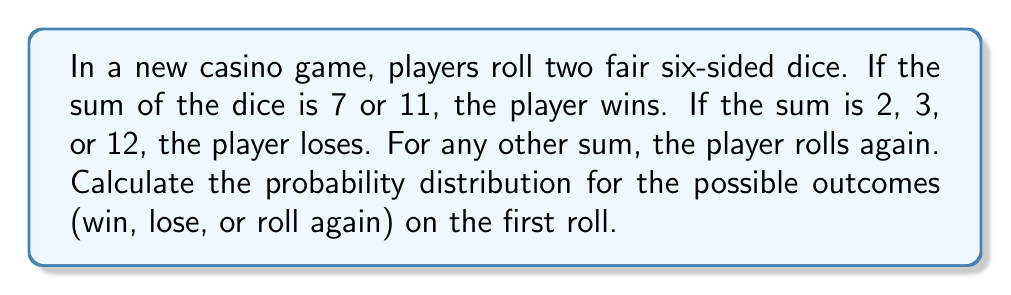Show me your answer to this math problem. Let's approach this step-by-step:

1) First, we need to identify all possible outcomes when rolling two dice:
   There are 36 possible combinations (6 x 6).

2) Now, let's count the favorable outcomes for each case:

   Win: Sum of 7 or 11
   - 7: (1,6), (2,5), (3,4), (4,3), (5,2), (6,1) → 6 ways
   - 11: (5,6), (6,5) → 2 ways
   Total winning combinations: 8

   Lose: Sum of 2, 3, or 12
   - 2: (1,1) → 1 way
   - 3: (1,2), (2,1) → 2 ways
   - 12: (6,6) → 1 way
   Total losing combinations: 4

   Roll again: Any other sum (4, 5, 6, 8, 9, 10)
   - Total combinations - (Win combinations + Lose combinations)
   - 36 - (8 + 4) = 24 combinations

3) Now we can calculate the probabilities:

   $P(\text{Win}) = \frac{\text{Favorable outcomes for winning}}{\text{Total outcomes}} = \frac{8}{36} = \frac{2}{9}$

   $P(\text{Lose}) = \frac{\text{Favorable outcomes for losing}}{\text{Total outcomes}} = \frac{4}{36} = \frac{1}{9}$

   $P(\text{Roll again}) = \frac{\text{Favorable outcomes for rolling again}}{\text{Total outcomes}} = \frac{24}{36} = \frac{2}{3}$

4) The probability distribution is thus:

   $$\begin{cases}
   P(\text{Win}) = \frac{2}{9} \\
   P(\text{Lose}) = \frac{1}{9} \\
   P(\text{Roll again}) = \frac{2}{3}
   \end{cases}$$
Answer: $P(\text{Win}) = \frac{2}{9}$, $P(\text{Lose}) = \frac{1}{9}$, $P(\text{Roll again}) = \frac{2}{3}$ 